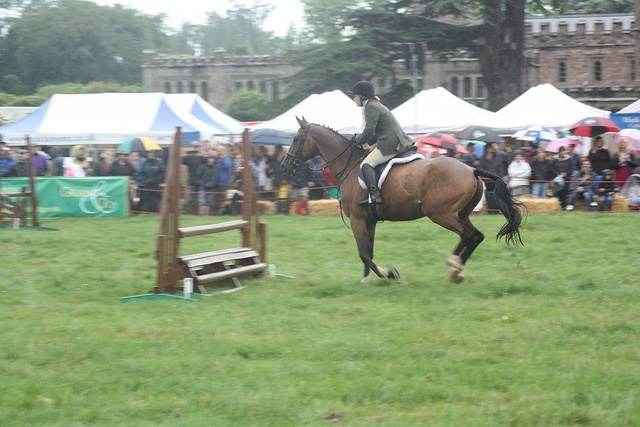Describe the objects in this image and their specific colors. I can see people in darkgray and gray tones, horse in darkgray, gray, and black tones, umbrella in darkgray, white, lightblue, and gray tones, people in darkgray, gray, lightgray, and purple tones, and umbrella in darkgray, white, gray, and lightpink tones in this image. 